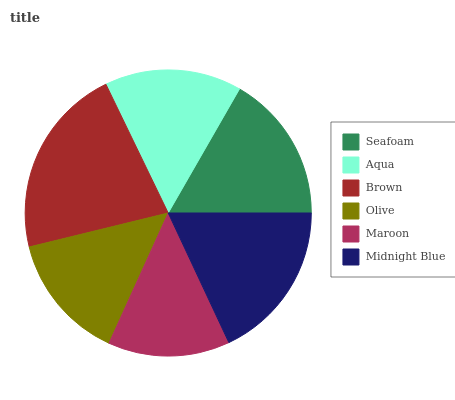Is Maroon the minimum?
Answer yes or no. Yes. Is Brown the maximum?
Answer yes or no. Yes. Is Aqua the minimum?
Answer yes or no. No. Is Aqua the maximum?
Answer yes or no. No. Is Seafoam greater than Aqua?
Answer yes or no. Yes. Is Aqua less than Seafoam?
Answer yes or no. Yes. Is Aqua greater than Seafoam?
Answer yes or no. No. Is Seafoam less than Aqua?
Answer yes or no. No. Is Seafoam the high median?
Answer yes or no. Yes. Is Aqua the low median?
Answer yes or no. Yes. Is Midnight Blue the high median?
Answer yes or no. No. Is Seafoam the low median?
Answer yes or no. No. 